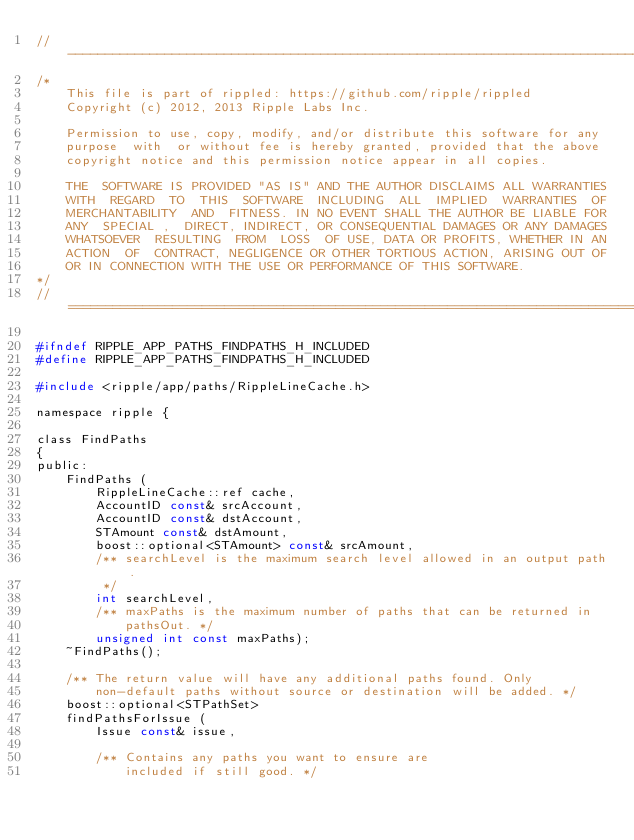<code> <loc_0><loc_0><loc_500><loc_500><_C_>//------------------------------------------------------------------------------
/*
    This file is part of rippled: https://github.com/ripple/rippled
    Copyright (c) 2012, 2013 Ripple Labs Inc.

    Permission to use, copy, modify, and/or distribute this software for any
    purpose  with  or without fee is hereby granted, provided that the above
    copyright notice and this permission notice appear in all copies.

    THE  SOFTWARE IS PROVIDED "AS IS" AND THE AUTHOR DISCLAIMS ALL WARRANTIES
    WITH  REGARD  TO  THIS  SOFTWARE  INCLUDING  ALL  IMPLIED  WARRANTIES  OF
    MERCHANTABILITY  AND  FITNESS. IN NO EVENT SHALL THE AUTHOR BE LIABLE FOR
    ANY  SPECIAL ,  DIRECT, INDIRECT, OR CONSEQUENTIAL DAMAGES OR ANY DAMAGES
    WHATSOEVER  RESULTING  FROM  LOSS  OF USE, DATA OR PROFITS, WHETHER IN AN
    ACTION  OF  CONTRACT, NEGLIGENCE OR OTHER TORTIOUS ACTION, ARISING OUT OF
    OR IN CONNECTION WITH THE USE OR PERFORMANCE OF THIS SOFTWARE.
*/
//==============================================================================

#ifndef RIPPLE_APP_PATHS_FINDPATHS_H_INCLUDED
#define RIPPLE_APP_PATHS_FINDPATHS_H_INCLUDED

#include <ripple/app/paths/RippleLineCache.h>

namespace ripple {

class FindPaths
{
public:
    FindPaths (
        RippleLineCache::ref cache,
        AccountID const& srcAccount,
        AccountID const& dstAccount,
        STAmount const& dstAmount,
        boost::optional<STAmount> const& srcAmount,
        /** searchLevel is the maximum search level allowed in an output path.
         */
        int searchLevel,
        /** maxPaths is the maximum number of paths that can be returned in
            pathsOut. */
        unsigned int const maxPaths);
    ~FindPaths();

    /** The return value will have any additional paths found. Only
        non-default paths without source or destination will be added. */
    boost::optional<STPathSet>
    findPathsForIssue (
        Issue const& issue,

        /** Contains any paths you want to ensure are
            included if still good. */</code> 